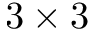Convert formula to latex. <formula><loc_0><loc_0><loc_500><loc_500>3 \times 3</formula> 